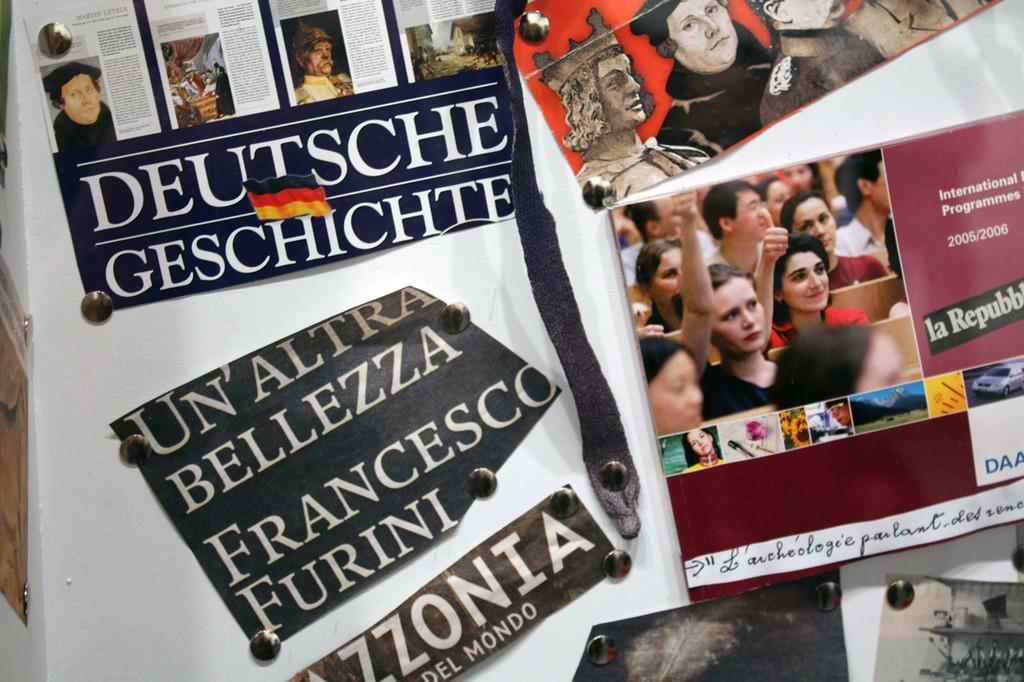What is displayed on the board in the image? There are papers printed on a board in the image. Can you describe the people in the image? There is a group of people in the image. What can be read or seen in terms of written content in the image? There is some text visible in the image. What direction are the people downtown in the image? There is no mention of downtown or a specific direction in the image. The image only shows a board with papers and a group of people. 